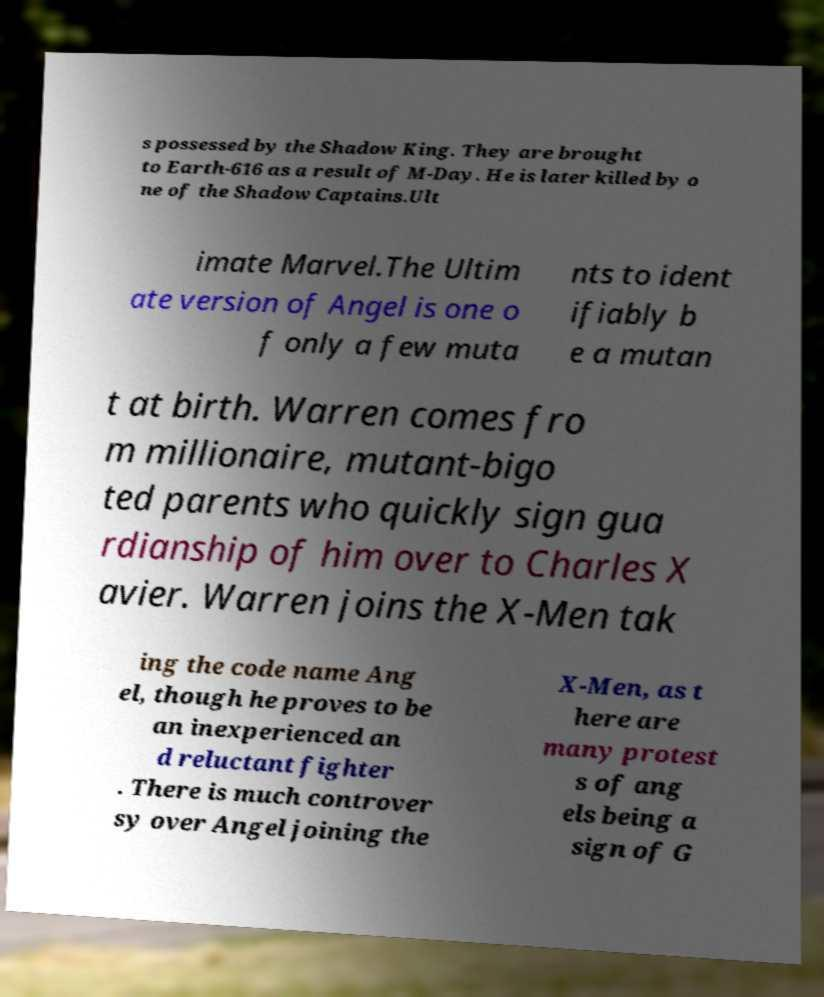Please identify and transcribe the text found in this image. s possessed by the Shadow King. They are brought to Earth-616 as a result of M-Day. He is later killed by o ne of the Shadow Captains.Ult imate Marvel.The Ultim ate version of Angel is one o f only a few muta nts to ident ifiably b e a mutan t at birth. Warren comes fro m millionaire, mutant-bigo ted parents who quickly sign gua rdianship of him over to Charles X avier. Warren joins the X-Men tak ing the code name Ang el, though he proves to be an inexperienced an d reluctant fighter . There is much controver sy over Angel joining the X-Men, as t here are many protest s of ang els being a sign of G 